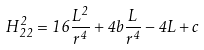<formula> <loc_0><loc_0><loc_500><loc_500>H _ { 2 2 } ^ { 2 } = 1 6 \frac { L ^ { 2 } } { r ^ { 4 } } + 4 b \frac { L } { r ^ { 4 } } - 4 L + c</formula> 